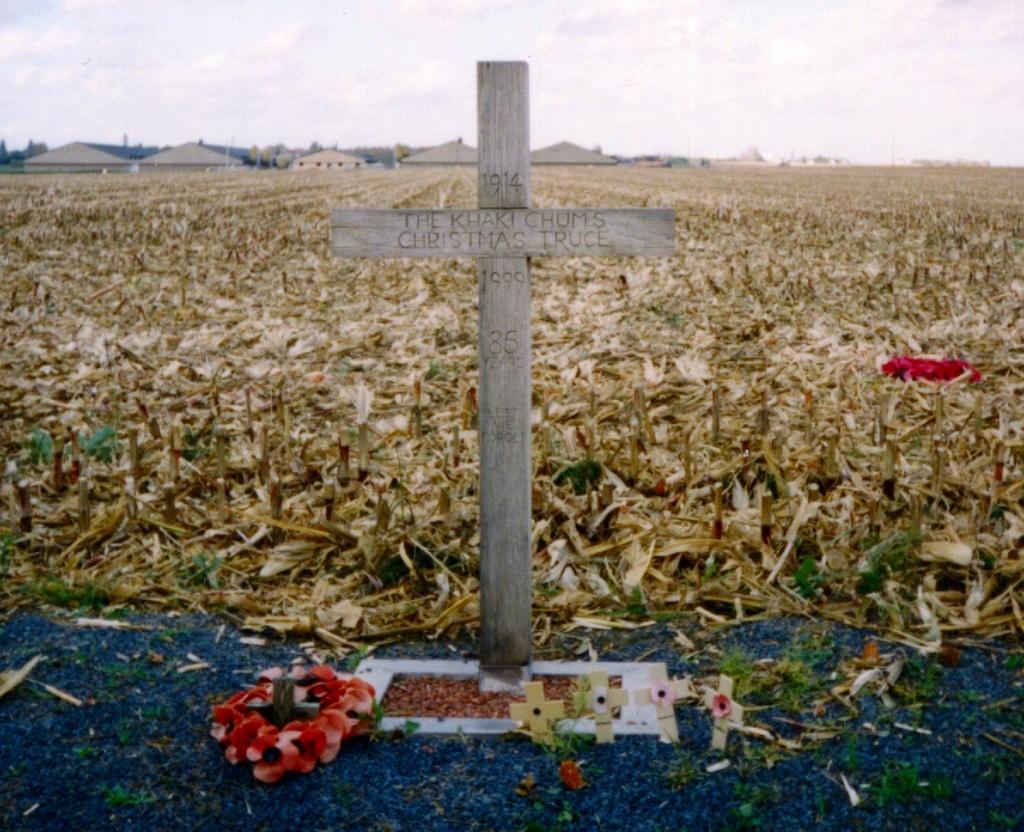In one or two sentences, can you explain what this image depicts? In the center of the image, we can see a cross on the grave and there are some flowers and some objects. In the background, there is field and we can see some seeds and trees. At the top, there is sky. 